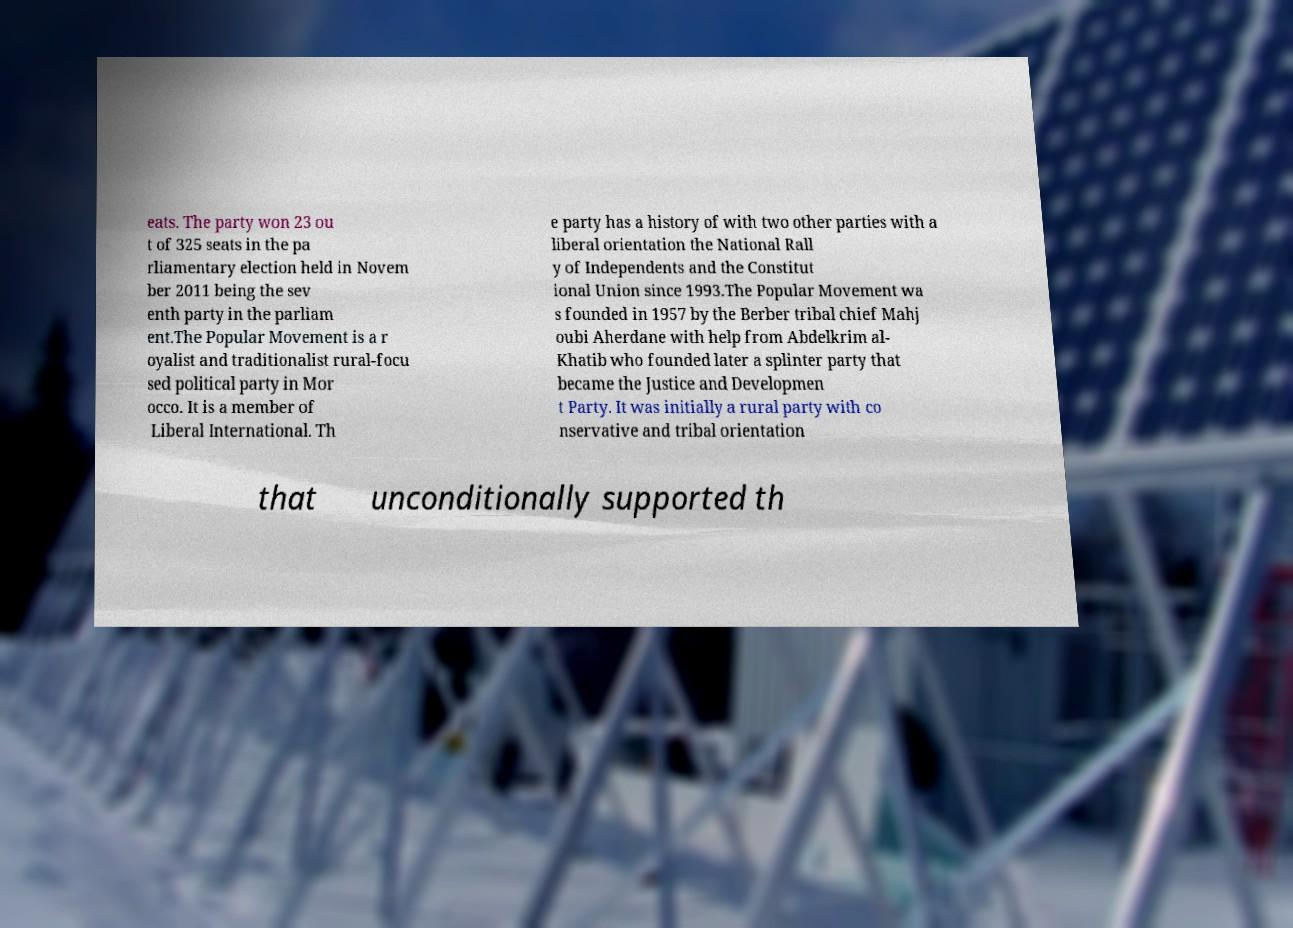Can you accurately transcribe the text from the provided image for me? eats. The party won 23 ou t of 325 seats in the pa rliamentary election held in Novem ber 2011 being the sev enth party in the parliam ent.The Popular Movement is a r oyalist and traditionalist rural-focu sed political party in Mor occo. It is a member of Liberal International. Th e party has a history of with two other parties with a liberal orientation the National Rall y of Independents and the Constitut ional Union since 1993.The Popular Movement wa s founded in 1957 by the Berber tribal chief Mahj oubi Aherdane with help from Abdelkrim al- Khatib who founded later a splinter party that became the Justice and Developmen t Party. It was initially a rural party with co nservative and tribal orientation that unconditionally supported th 